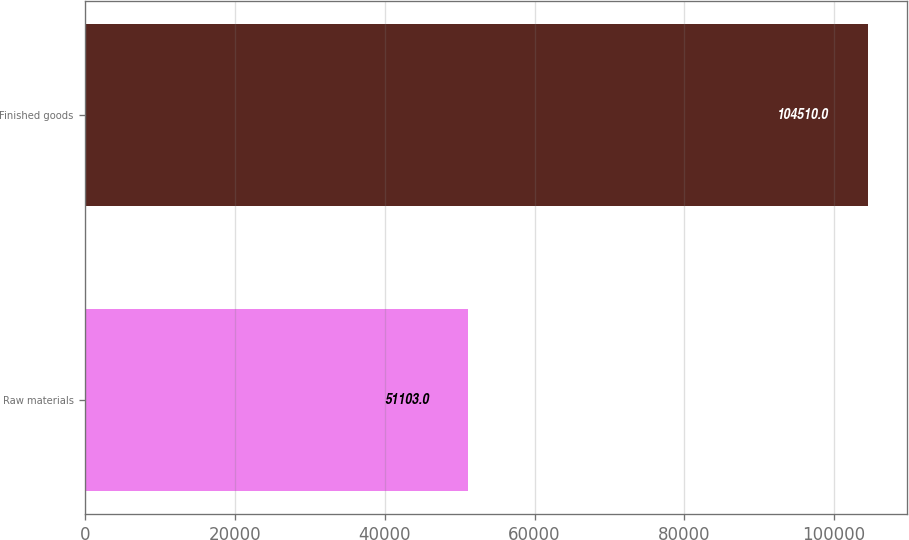Convert chart. <chart><loc_0><loc_0><loc_500><loc_500><bar_chart><fcel>Raw materials<fcel>Finished goods<nl><fcel>51103<fcel>104510<nl></chart> 